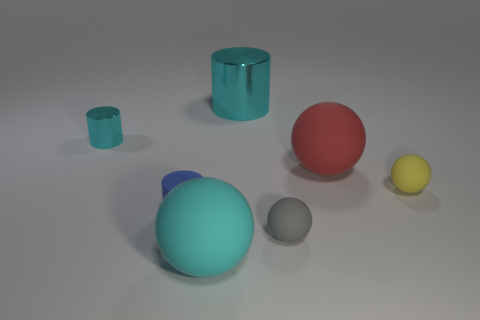There is a gray rubber object; does it have the same shape as the metallic object left of the blue matte cylinder? The gray rubber object appears to be spherical, which is a different shape compared to the metallic object to the left of the blue cylinder, which is cylindrical. Though these two objects have different shapes, they both exhibit roundness in their own dimensions, the sphere being round in three dimensions while the cylinder is round in two and flat on the ends. 